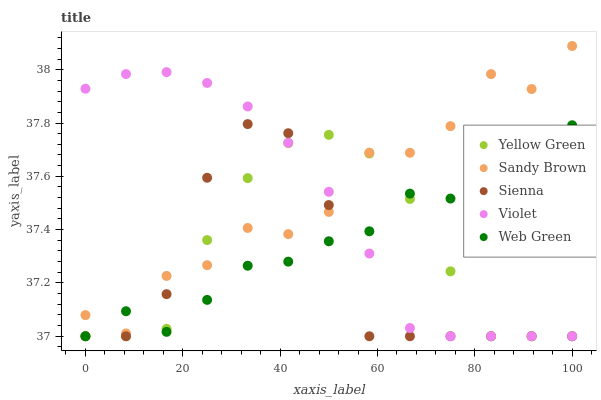Does Sienna have the minimum area under the curve?
Answer yes or no. Yes. Does Sandy Brown have the maximum area under the curve?
Answer yes or no. Yes. Does Yellow Green have the minimum area under the curve?
Answer yes or no. No. Does Yellow Green have the maximum area under the curve?
Answer yes or no. No. Is Violet the smoothest?
Answer yes or no. Yes. Is Sienna the roughest?
Answer yes or no. Yes. Is Sandy Brown the smoothest?
Answer yes or no. No. Is Sandy Brown the roughest?
Answer yes or no. No. Does Sienna have the lowest value?
Answer yes or no. Yes. Does Sandy Brown have the lowest value?
Answer yes or no. No. Does Sandy Brown have the highest value?
Answer yes or no. Yes. Does Yellow Green have the highest value?
Answer yes or no. No. Does Sienna intersect Sandy Brown?
Answer yes or no. Yes. Is Sienna less than Sandy Brown?
Answer yes or no. No. Is Sienna greater than Sandy Brown?
Answer yes or no. No. 